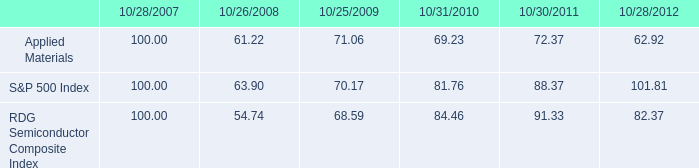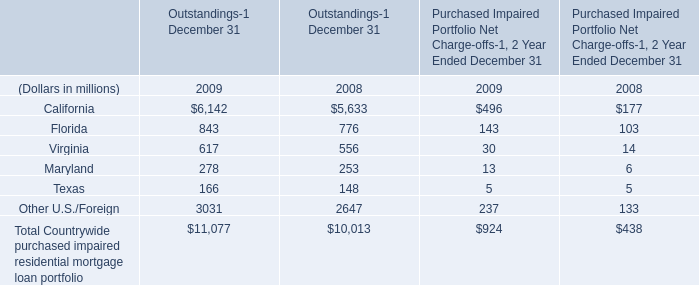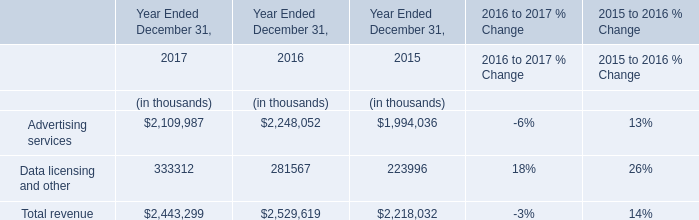In the year with the most Total Countrywide purchased impaired residential mortgage loan portfolio, what is the growth rate of Virginia? 
Computations: ((30 - 14) / 14)
Answer: 1.14286. 